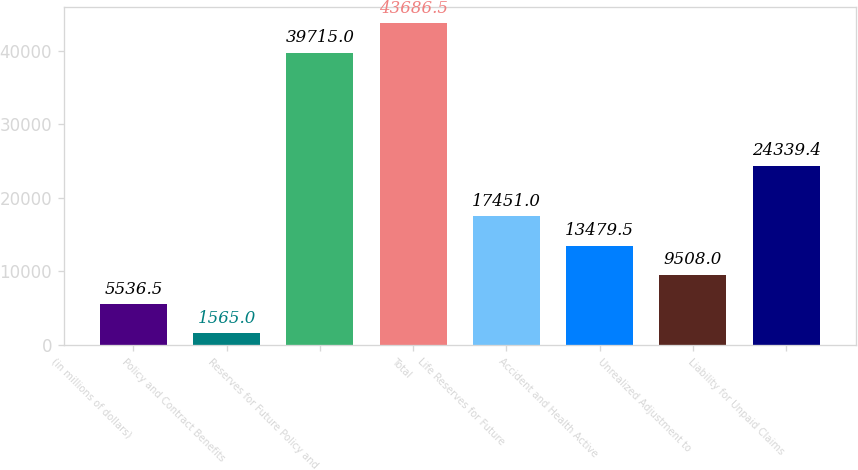Convert chart to OTSL. <chart><loc_0><loc_0><loc_500><loc_500><bar_chart><fcel>(in millions of dollars)<fcel>Policy and Contract Benefits<fcel>Reserves for Future Policy and<fcel>Total<fcel>Life Reserves for Future<fcel>Accident and Health Active<fcel>Unrealized Adjustment to<fcel>Liability for Unpaid Claims<nl><fcel>5536.5<fcel>1565<fcel>39715<fcel>43686.5<fcel>17451<fcel>13479.5<fcel>9508<fcel>24339.4<nl></chart> 